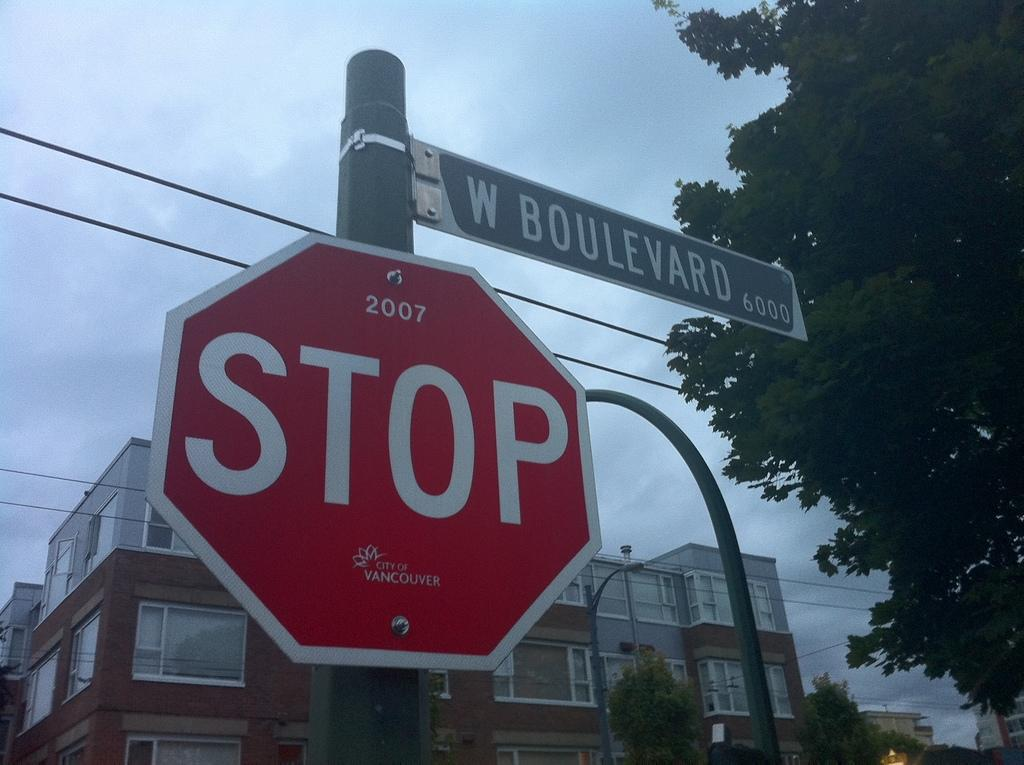<image>
Summarize the visual content of the image. a stop sign that has the word boulevard above it 